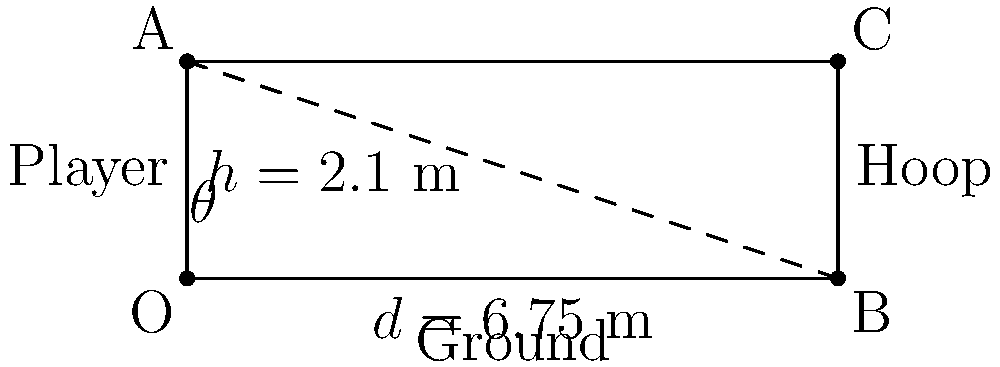As a sports journalist analyzing a star shooting guard's incredible three-point shot, you want to calculate the angle of the shot's trajectory. The player releases the ball from a height of 2.1 meters, and the distance to the hoop is 6.75 meters (the three-point line distance). Assuming the hoop is at regulation height of 3.05 meters, what is the angle $\theta$ (in degrees) of the shot's trajectory? To solve this problem, we'll use trigonometry. Let's break it down step-by-step:

1) First, we need to find the height difference between the release point and the hoop:
   $\text{Height difference} = 3.05\text{ m} - 2.1\text{ m} = 0.95\text{ m}$

2) Now we have a right triangle where:
   - The adjacent side is the horizontal distance: 6.75 m
   - The opposite side is the height difference: 0.95 m

3) We can use the arctangent function to find the angle:
   $\theta = \arctan(\frac{\text{opposite}}{\text{adjacent}})$

4) Plugging in our values:
   $\theta = \arctan(\frac{0.95}{6.75})$

5) Using a calculator or computer:
   $\theta \approx 8.0175$ degrees

6) Rounding to two decimal places:
   $\theta \approx 8.02$ degrees

This angle represents the minimum trajectory needed for the ball to reach the hoop, assuming no air resistance and neglecting the ball's arc.
Answer: $8.02°$ 